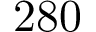Convert formula to latex. <formula><loc_0><loc_0><loc_500><loc_500>2 8 0</formula> 